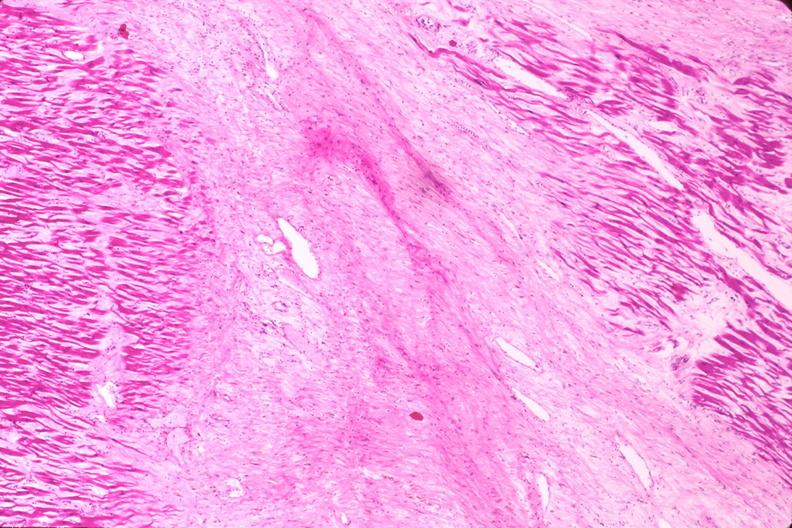does this image show heart, myocardial infarction free wall, 6 days old, in a patient with diabetes mellitus and hypertension?
Answer the question using a single word or phrase. Yes 